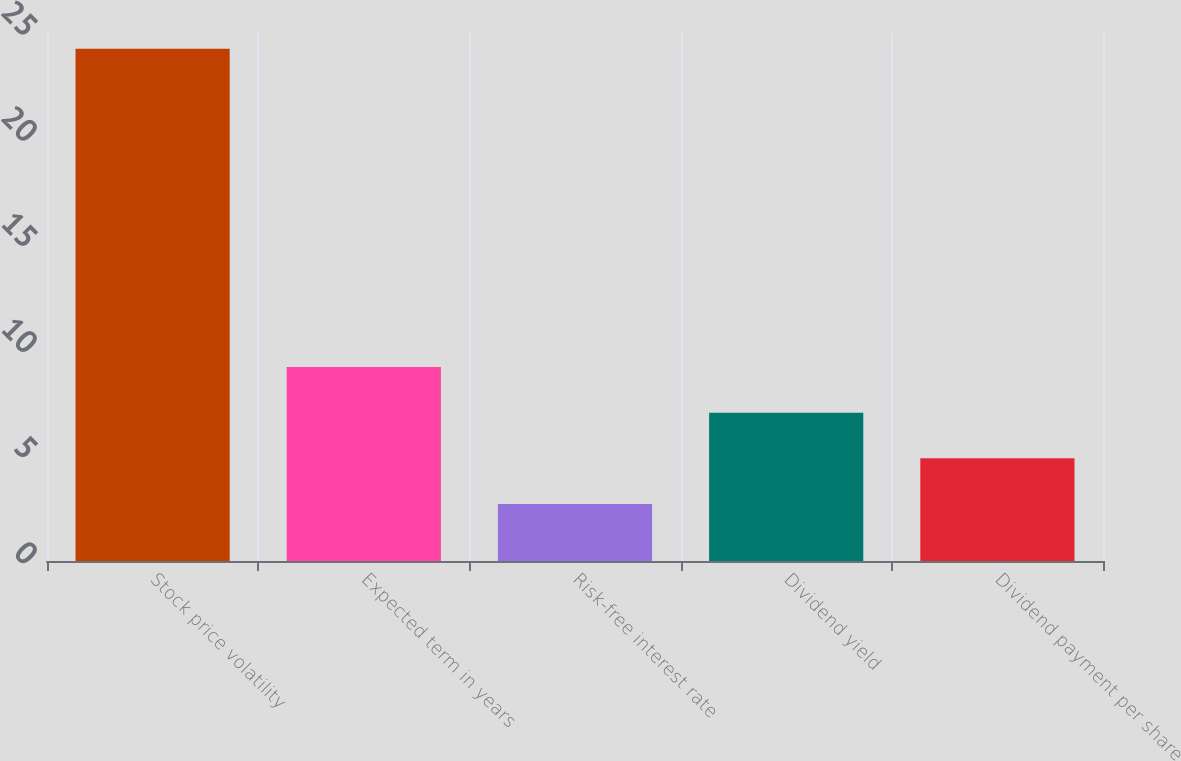<chart> <loc_0><loc_0><loc_500><loc_500><bar_chart><fcel>Stock price volatility<fcel>Expected term in years<fcel>Risk-free interest rate<fcel>Dividend yield<fcel>Dividend payment per share<nl><fcel>24.25<fcel>9.18<fcel>2.7<fcel>7.02<fcel>4.86<nl></chart> 